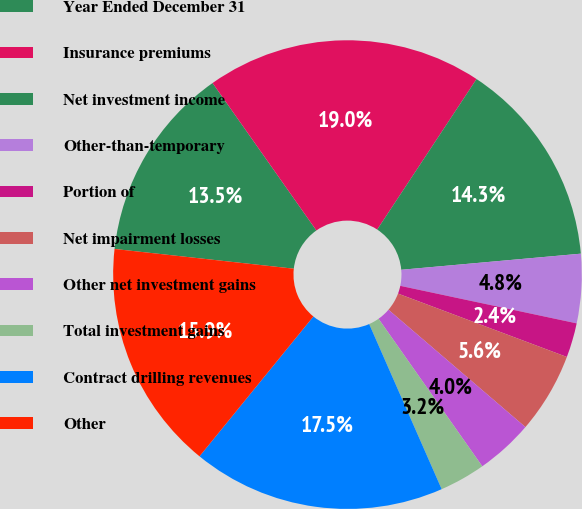<chart> <loc_0><loc_0><loc_500><loc_500><pie_chart><fcel>Year Ended December 31<fcel>Insurance premiums<fcel>Net investment income<fcel>Other-than-temporary<fcel>Portion of<fcel>Net impairment losses<fcel>Other net investment gains<fcel>Total investment gains<fcel>Contract drilling revenues<fcel>Other<nl><fcel>13.49%<fcel>19.05%<fcel>14.29%<fcel>4.76%<fcel>2.38%<fcel>5.56%<fcel>3.97%<fcel>3.17%<fcel>17.46%<fcel>15.87%<nl></chart> 